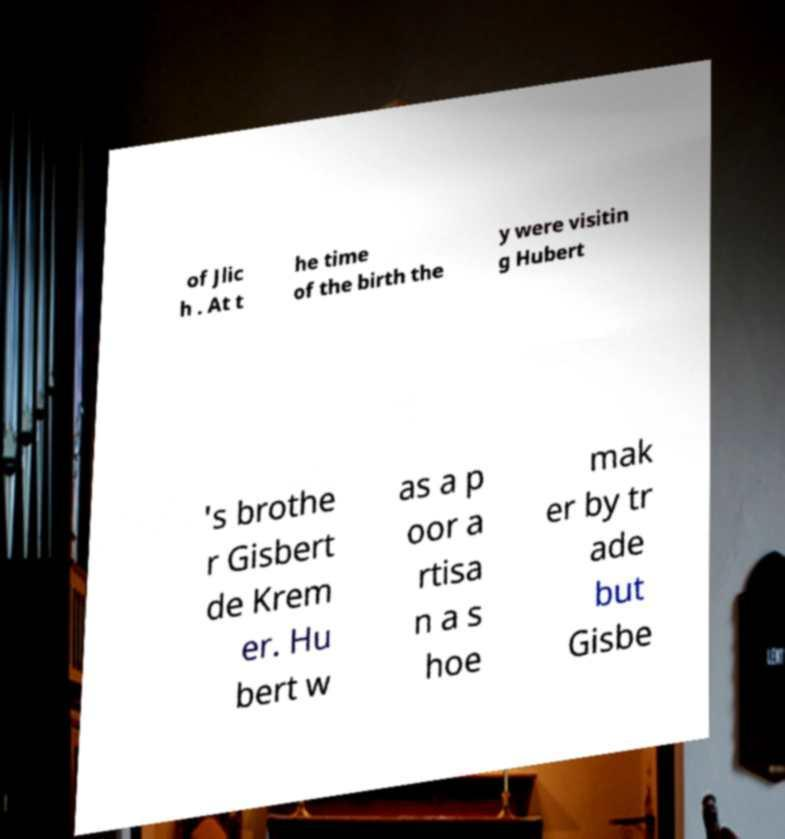There's text embedded in this image that I need extracted. Can you transcribe it verbatim? of Jlic h . At t he time of the birth the y were visitin g Hubert 's brothe r Gisbert de Krem er. Hu bert w as a p oor a rtisa n a s hoe mak er by tr ade but Gisbe 